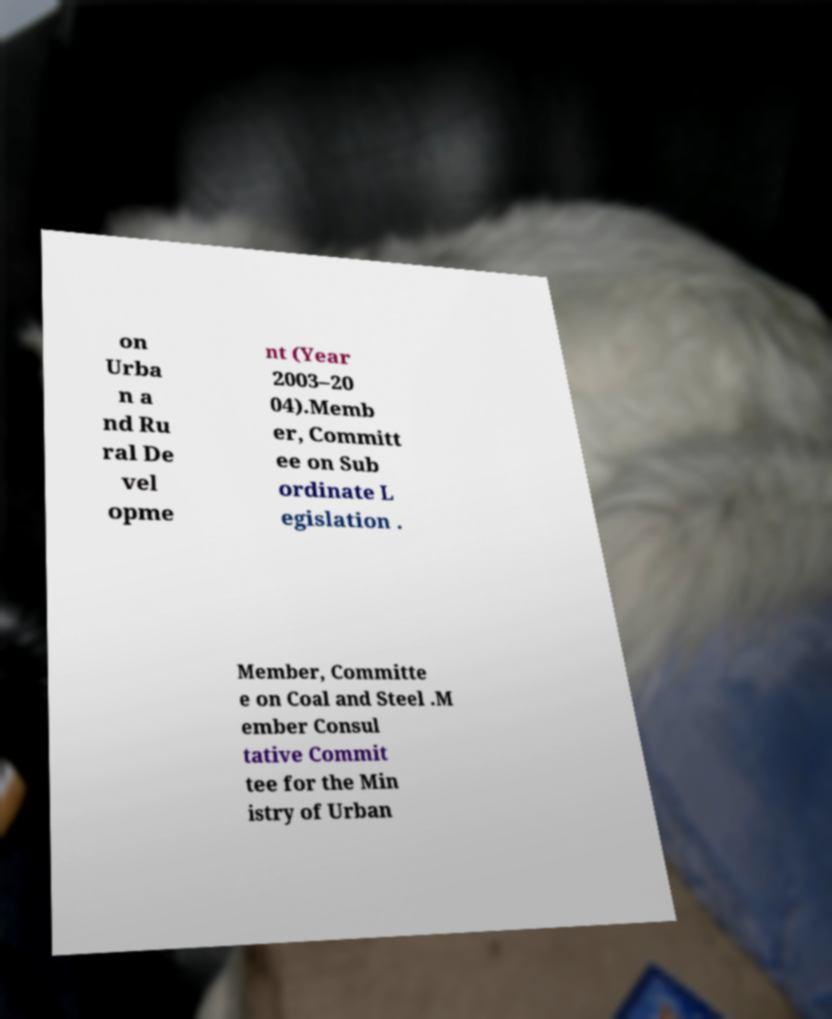What messages or text are displayed in this image? I need them in a readable, typed format. on Urba n a nd Ru ral De vel opme nt (Year 2003–20 04).Memb er, Committ ee on Sub ordinate L egislation . Member, Committe e on Coal and Steel .M ember Consul tative Commit tee for the Min istry of Urban 